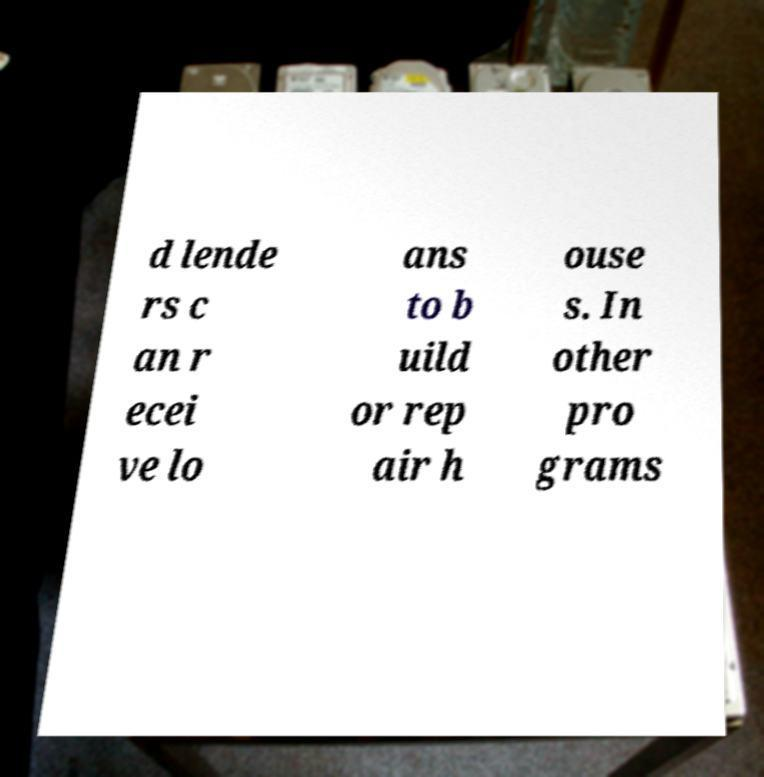Please read and relay the text visible in this image. What does it say? d lende rs c an r ecei ve lo ans to b uild or rep air h ouse s. In other pro grams 